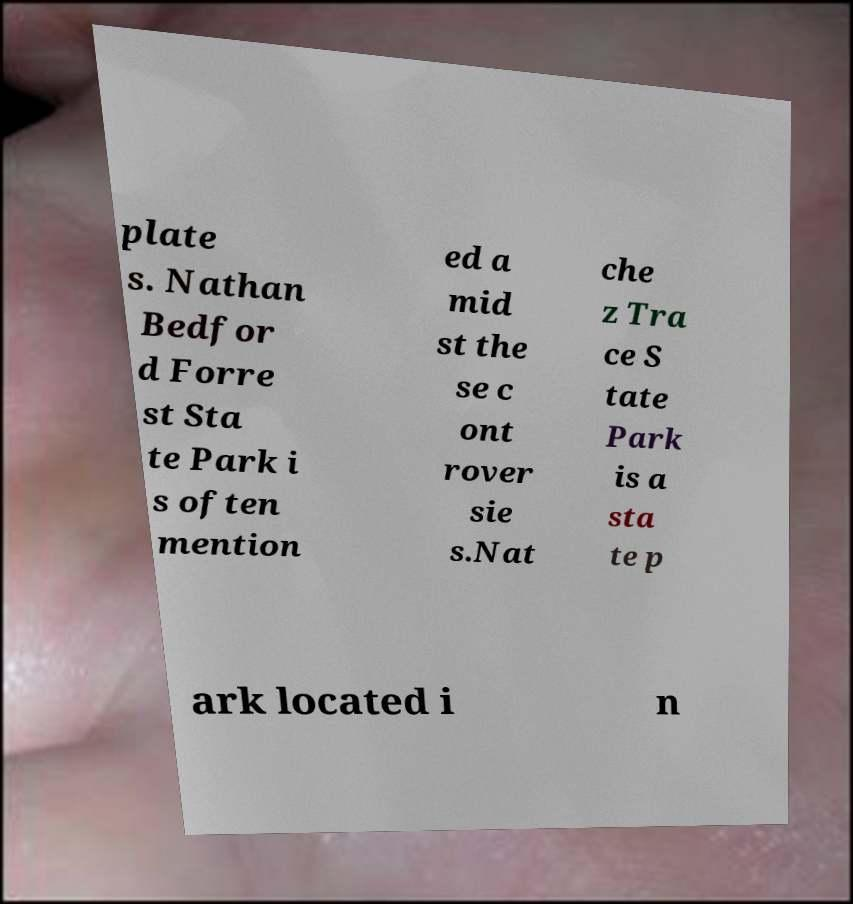What messages or text are displayed in this image? I need them in a readable, typed format. plate s. Nathan Bedfor d Forre st Sta te Park i s often mention ed a mid st the se c ont rover sie s.Nat che z Tra ce S tate Park is a sta te p ark located i n 